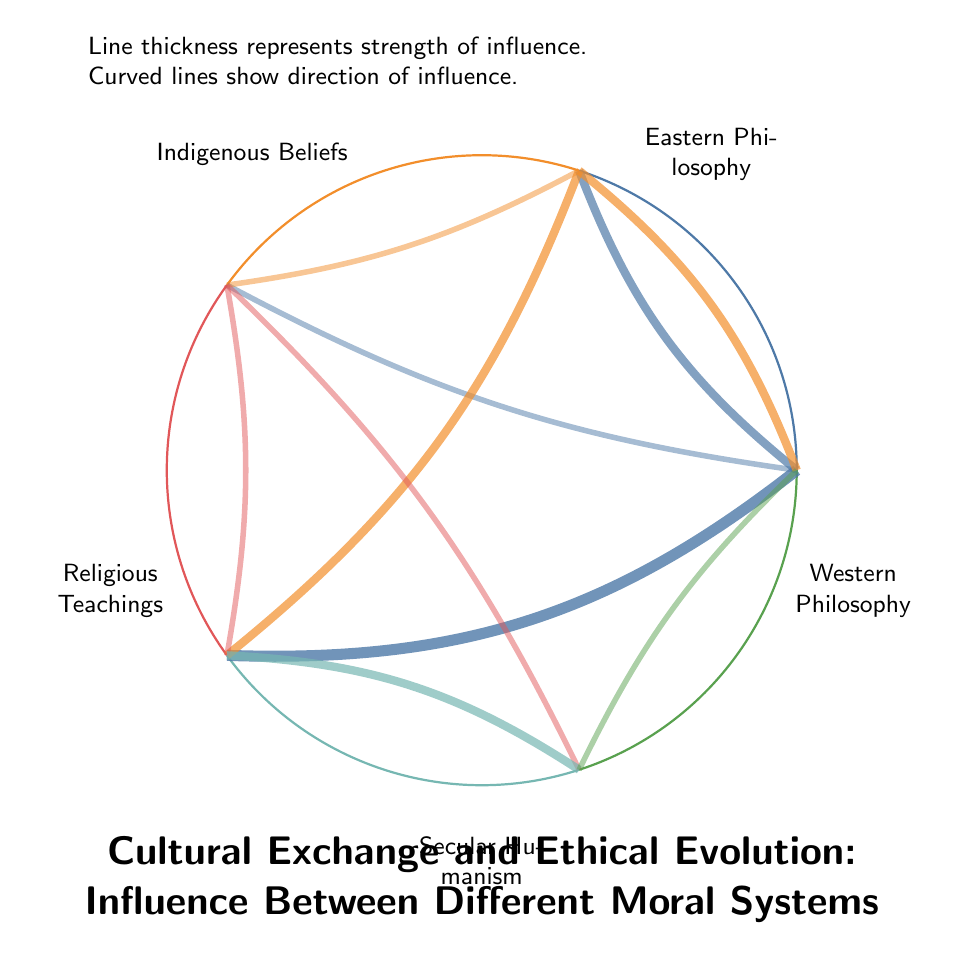What are the total number of nodes in the diagram? The diagram lists different cultures as nodes: Western Philosophy, Eastern Philosophy, Indigenous Beliefs, Religious Teachings, and Secular Humanism. Counting these gives a total of 5 nodes.
Answer: 5 Which cultural belief has the highest number of connections? Examining the links shows that Western Philosophy connects to Eastern Philosophy (3), Indigenous Beliefs (2), and Religious Teachings (4). The highest connection value here is 4, leading to Religious Teachings.
Answer: Religious Teachings What is the value of the connection between Eastern Philosophy and Religious Teachings? The link data highlight that Eastern Philosophy connects to Religious Teachings with a value of 3. This value indicates the strength of influence between these two nodes.
Answer: 3 How many connections does Secular Humanism have? Looking at the links, Secular Humanism connects with Religious Teachings (3), Indigenous Beliefs (2), and Western Philosophy (2), giving it a total of 4 connections.
Answer: 4 What is the influence strength of Western Philosophy on Indigenous Beliefs? The value of the link between Western Philosophy and Indigenous Beliefs is given as 2 in the link data. This measures the level of influence one has on the other.
Answer: 2 What relationship exists between Indigenous Beliefs and Secular Humanism? The diagram shows a link between Indigenous Beliefs and Secular Humanism with a value of 2, representing a degree of influence in the ethical evolution between them.
Answer: 2 Which two cultures exchange influence with the same strength of 2? After checking the connection values, both Eastern Philosophy and Indigenous Beliefs connect with Western Philosophy as well as Secular Humanism, each implying influence strengths of 2.
Answer: Eastern Philosophy and Indigenous Beliefs What is the main ethical concept that integrates Buddhism into Western practices? The influence of Eastern Philosophy on Western Philosophy can be traced through the integration of Buddhist concepts into mindfulness practices, highlighting a significant cultural exchange.
Answer: Mindfulness practices How does the influence from Religious Teachings to Secular Humanism manifest? The link data indicate that the influence strength of Religious Teachings on Secular Humanism is 3. This reflects that moral frameworks in secularism have been notably shaped by Christian ethics.
Answer: 3 